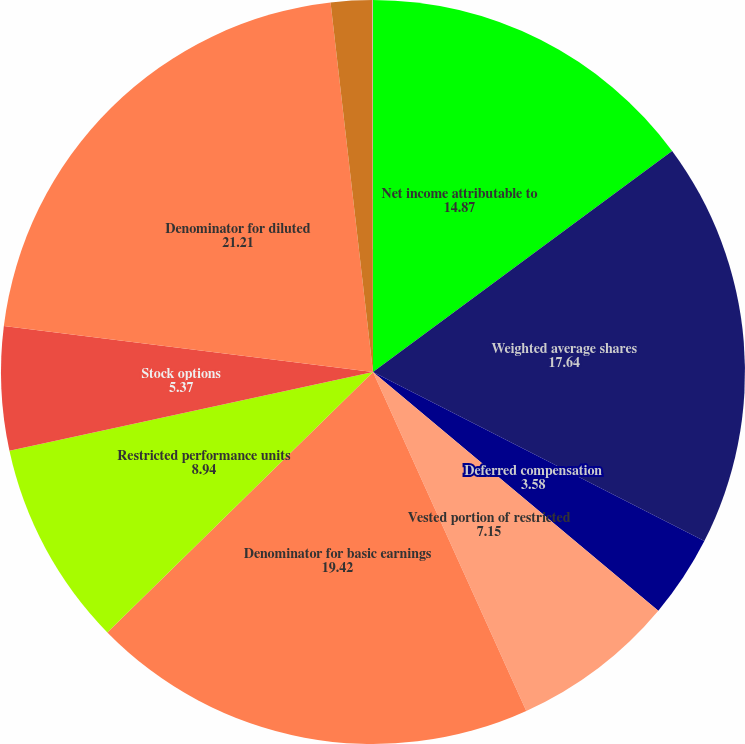Convert chart to OTSL. <chart><loc_0><loc_0><loc_500><loc_500><pie_chart><fcel>Net income attributable to<fcel>Weighted average shares<fcel>Deferred compensation<fcel>Vested portion of restricted<fcel>Denominator for basic earnings<fcel>Restricted performance units<fcel>Stock options<fcel>Denominator for diluted<fcel>Basic earnings per share<fcel>Diluted earnings per share<nl><fcel>14.87%<fcel>17.64%<fcel>3.58%<fcel>7.15%<fcel>19.42%<fcel>8.94%<fcel>5.37%<fcel>21.21%<fcel>1.8%<fcel>0.02%<nl></chart> 